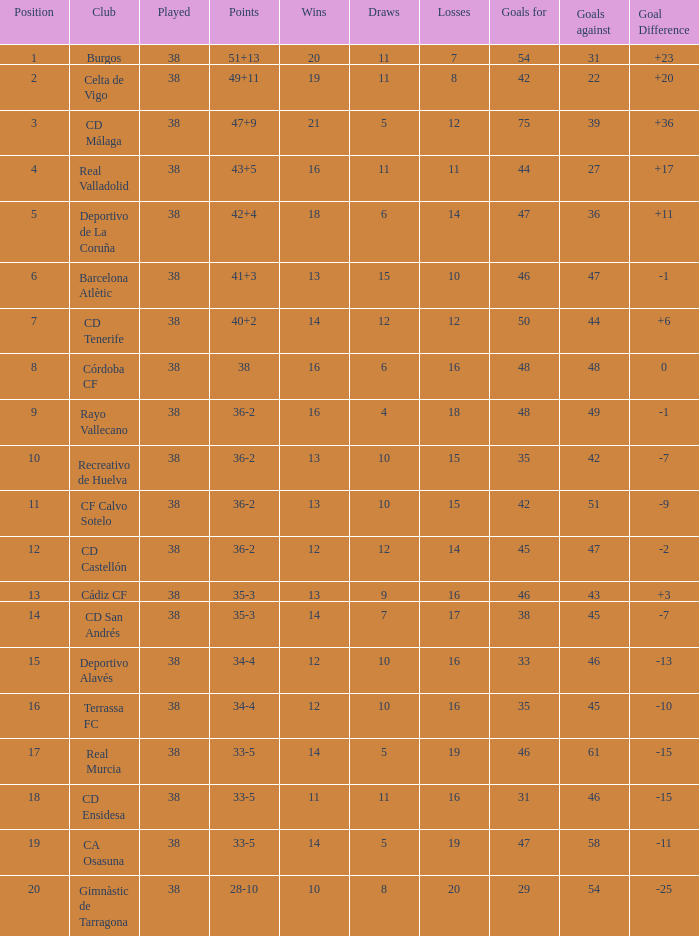How many positions have 14 wins, goals against of 61 and fewer than 19 losses? 0.0. 